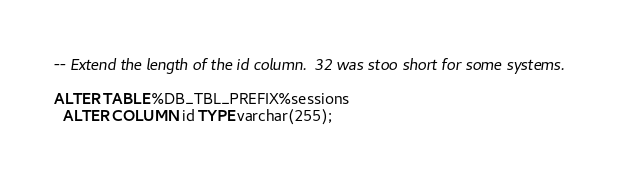Convert code to text. <code><loc_0><loc_0><loc_500><loc_500><_SQL_>-- Extend the length of the id column.  32 was stoo short for some systems.

ALTER TABLE %DB_TBL_PREFIX%sessions
  ALTER COLUMN id TYPE varchar(255);
</code> 